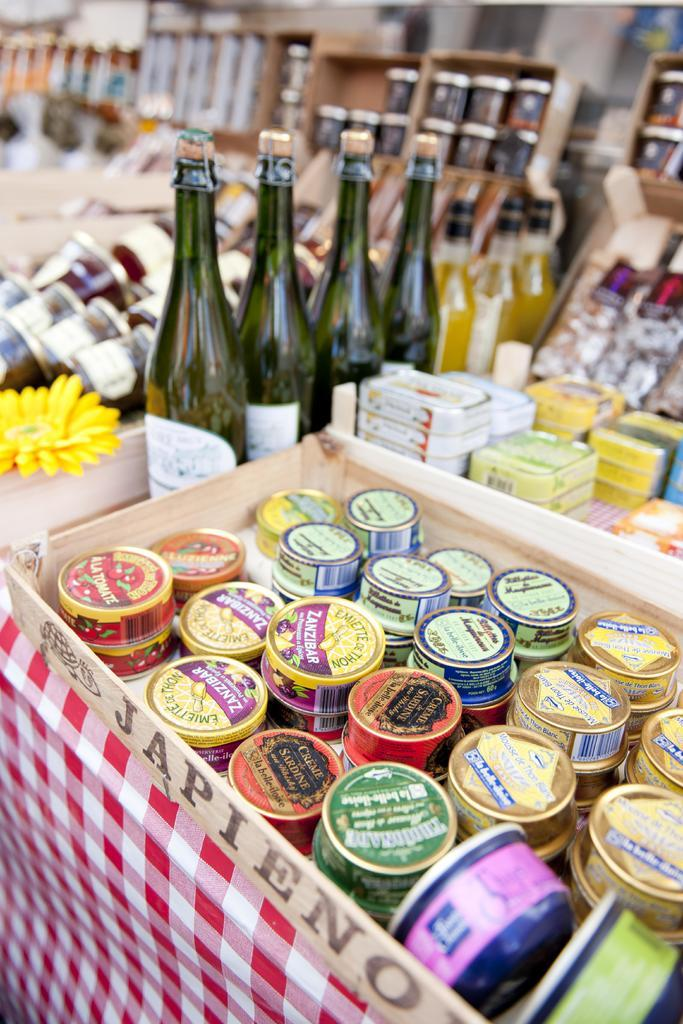<image>
Give a short and clear explanation of the subsequent image. Bottles next to tiny containers which say "CREME" on it. 